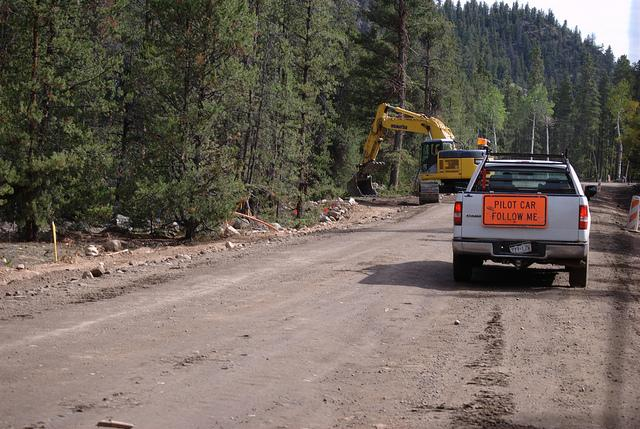What are you instructed to do?

Choices:
A) watch out
B) follow car
C) turn left
D) stop follow car 